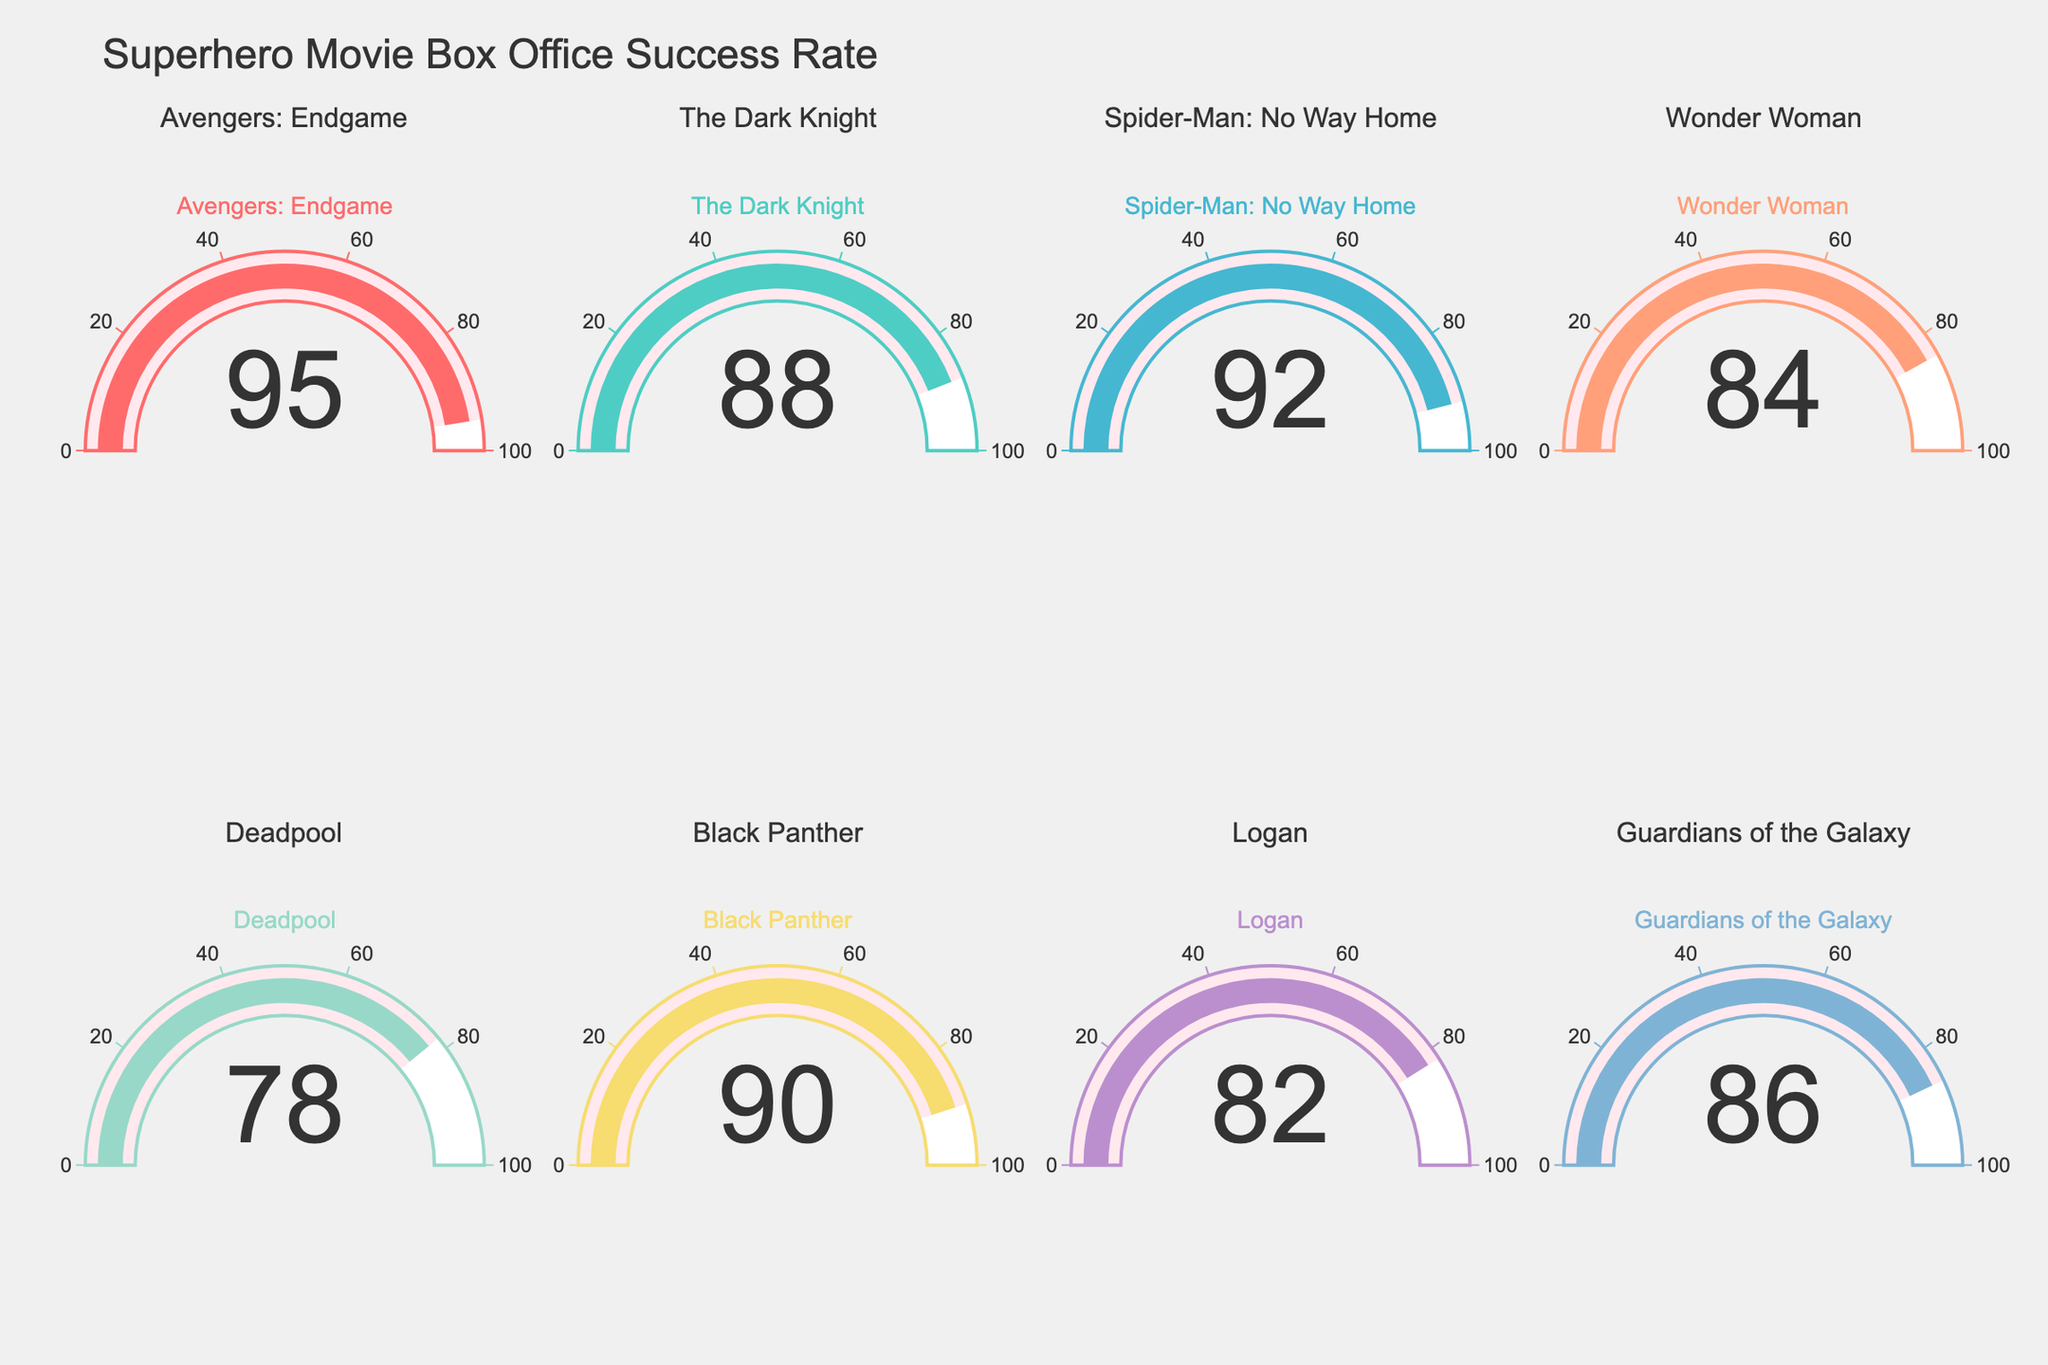What is the title of the plot? The title is displayed prominently at the top of the figure.
Answer: Superhero Movie Box Office Success Rate Which movie has the highest success rate? The gauge for "Avengers: Endgame" points near the top end, showing a value of 95.
Answer: Avengers: Endgame Identify the movie with the lowest success rate from the plot. The gauge for "Deadpool" has the lowest reading, at 78.
Answer: Deadpool What is the success rate of "Black Panther"? The gauge for "Black Panther" indicates a success rate of 90.
Answer: 90 How many movies are shown in the plot? There are 8 separate gauges, each representing one movie.
Answer: 8 What is the average success rate of all the movies combined? Add all success rates and divide by the total number of movies: (95 + 88 + 92 + 84 + 78 + 90 + 82 + 86) / 8 = 86.875.
Answer: 86.88 Which movie has a success rate closest to 85? Compare the values: "Guardians of the Galaxy" has a success rate of 86, which is closest to 85.
Answer: Guardians of the Galaxy What is the difference in success rate between "The Dark Knight" and "Wonder Woman"? Subtract the success rate of "Wonder Woman" from "The Dark Knight": 88 - 84 = 4.
Answer: 4 Which movie's gauge is colored blue? The gauge colors are unique, with blue color used for "Spider-Man: No Way Home".
Answer: Spider-Man: No Way Home How many movies have a success rate above 90? Count the movies with success rates more than 90: "Avengers: Endgame" (95) and "Spider-Man: No Way Home" (92).
Answer: 2 